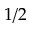<formula> <loc_0><loc_0><loc_500><loc_500>1 / 2</formula> 